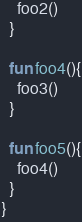Convert code to text. <code><loc_0><loc_0><loc_500><loc_500><_Kotlin_>    foo2()
  }

  fun foo4(){
    foo3()
  }

  fun foo5(){
    foo4()
  }
}</code> 